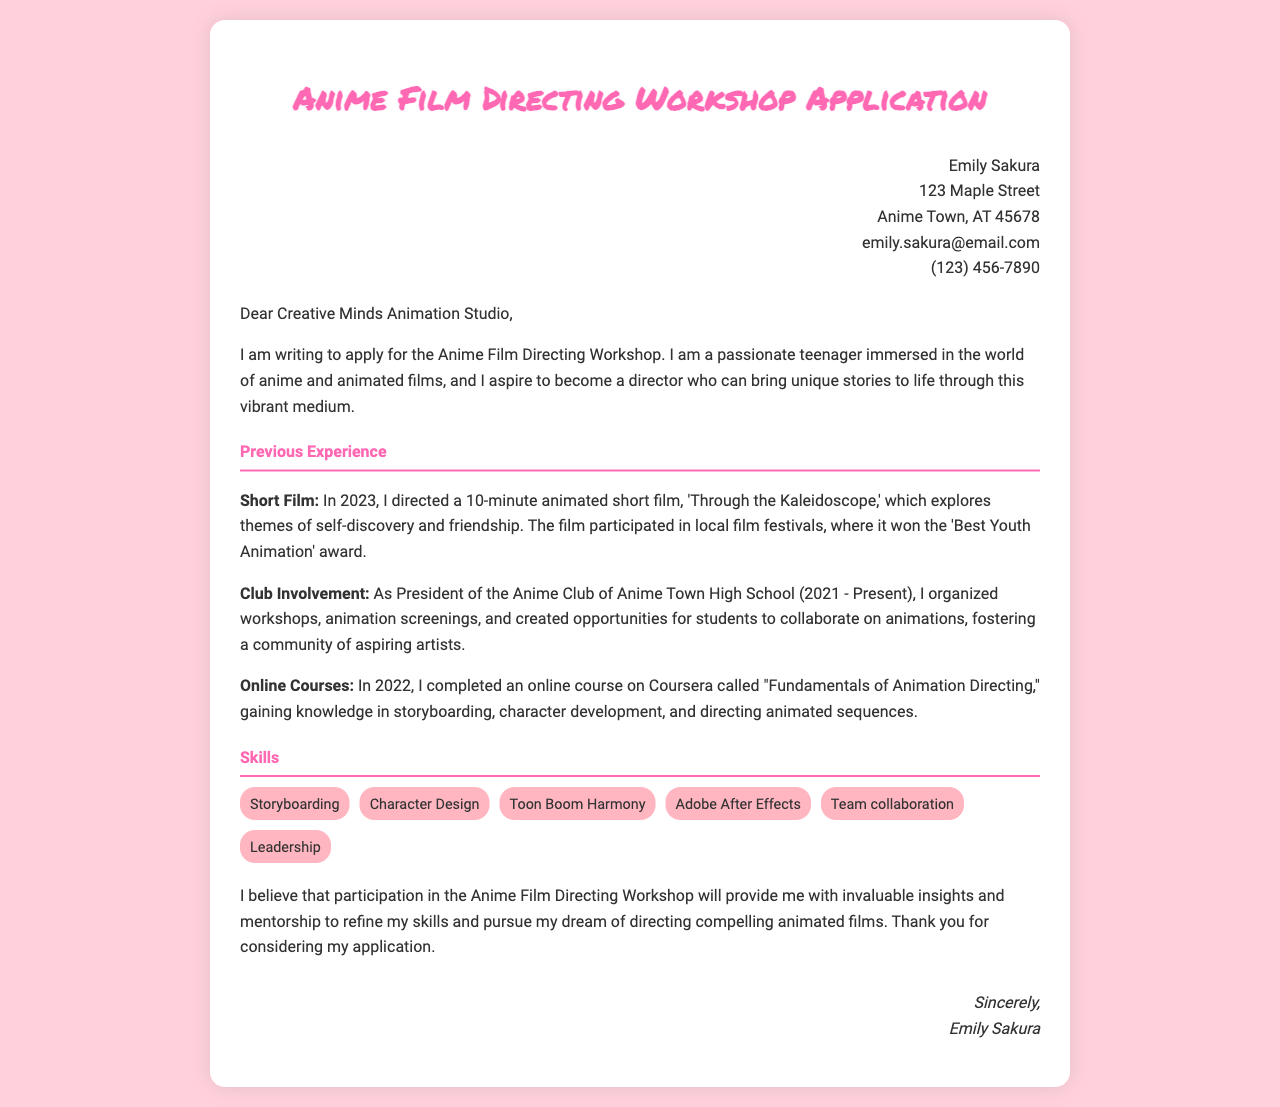What is the applicant's name? The applicant's name is presented at the top of the letter as "Emily Sakura."
Answer: Emily Sakura What is the title of the short film directed by the applicant? The applicant mentions their short film titled "Through the Kaleidoscope" in the document.
Answer: Through the Kaleidoscope What award did the short film win? The document states that the film won the "Best Youth Animation" award at local film festivals.
Answer: Best Youth Animation How long is the animated short film directed by the applicant? The letter specifies that the short film is 10 minutes long.
Answer: 10 minutes What position does the applicant hold in the Anime Club? The document indicates that the applicant is the President of the Anime Club at Anime Town High School.
Answer: President In what year did the applicant complete the online course? The applicant states they completed the online course in 2022.
Answer: 2022 What is one of the skills listed in the document? The letter includes multiple skills, one of which is "Storyboarding."
Answer: Storyboarding What is the main reason for applying to the workshop? The applicant believes the workshop will provide invaluable insights and mentorship to refine their skills.
Answer: Invaluable insights and mentorship What is the address provided in the letter? The applicant's address is mentioned at the top of the letter as "123 Maple Street, Anime Town, AT 45678."
Answer: 123 Maple Street, Anime Town, AT 45678 